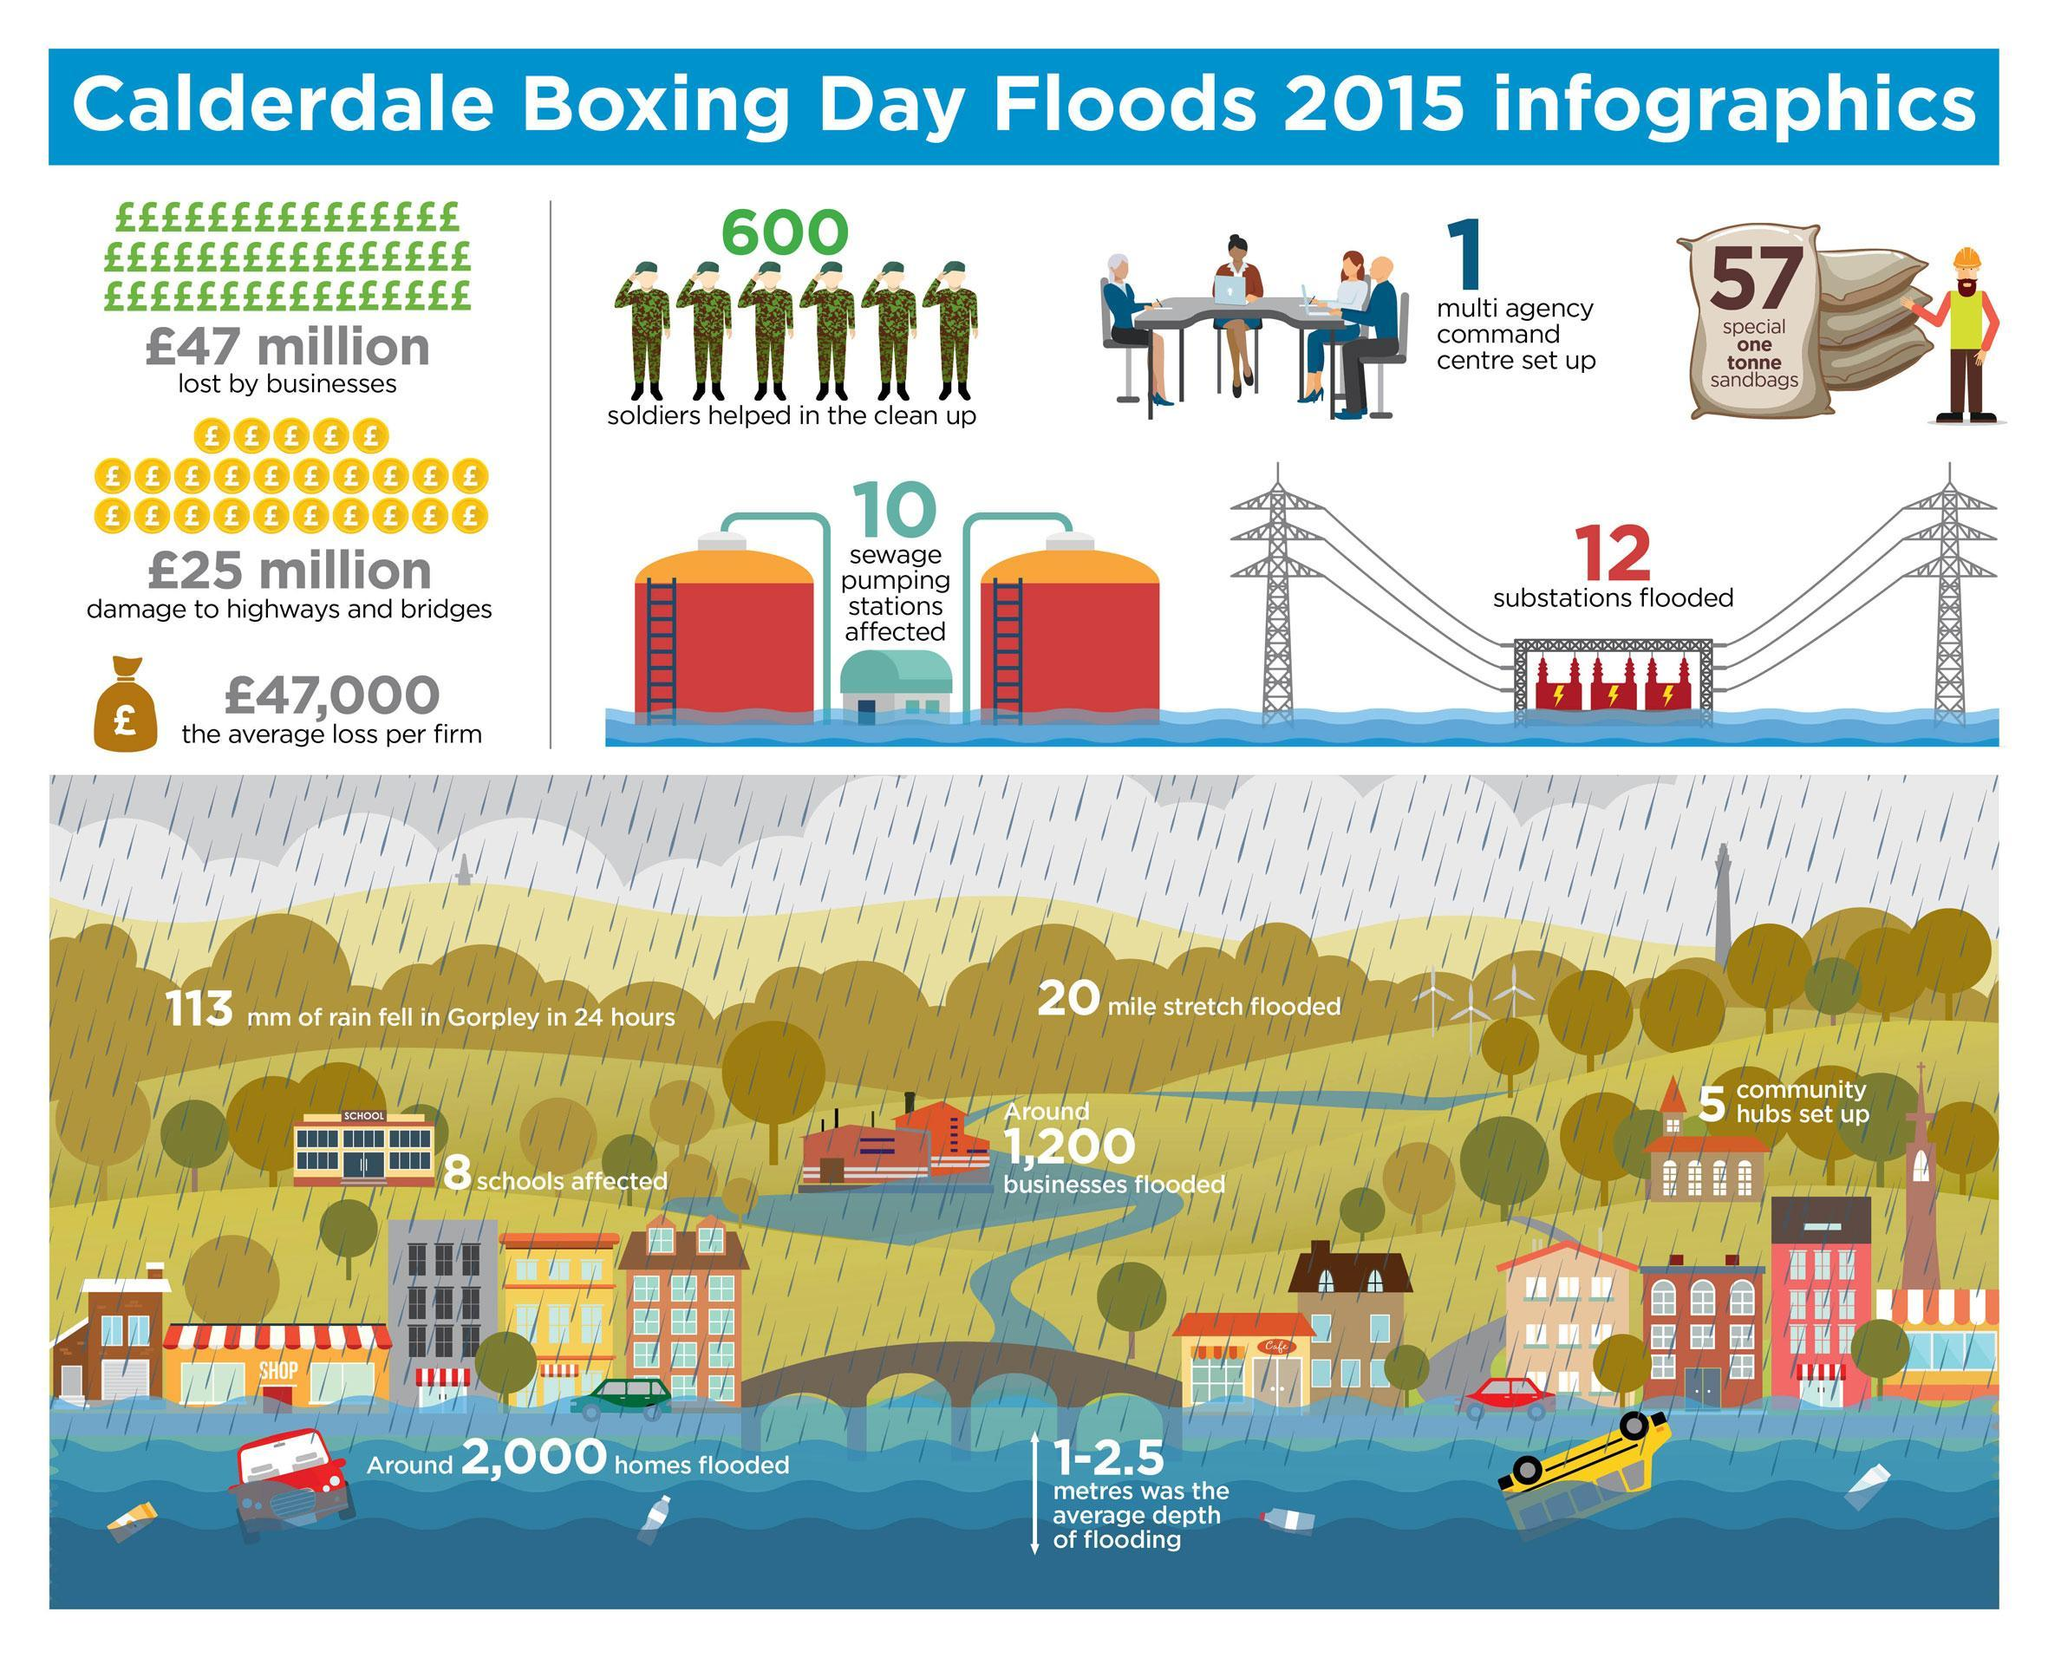What is the average depth of the flooding ?
Answer the question with a short phrase. 1-2.5 What was the average loss per firm ? £ 47,000 Approximately how many businesses were flooded ? 1,200 What is the weight of each sandbag ? One tonne How many soldiers helped clean up after the flood ? 600 How many sewage pumping stations were affected by the flood ? 10 How many substations were flooded ? 12 How many vehicles are seen floating in the flood water ? 2 How many multi-agency command centres were setup ? 1 How many soldiers are shown in the image ? 6 